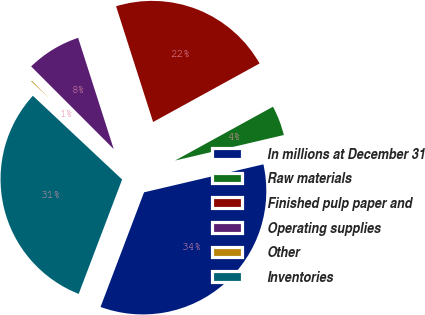Convert chart. <chart><loc_0><loc_0><loc_500><loc_500><pie_chart><fcel>In millions at December 31<fcel>Raw materials<fcel>Finished pulp paper and<fcel>Operating supplies<fcel>Other<fcel>Inventories<nl><fcel>34.44%<fcel>4.33%<fcel>21.93%<fcel>7.56%<fcel>0.52%<fcel>31.21%<nl></chart> 